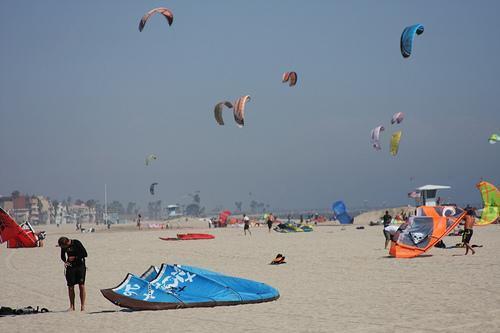How many kites are in the picture?
Give a very brief answer. 2. How many zebras are standing?
Give a very brief answer. 0. 